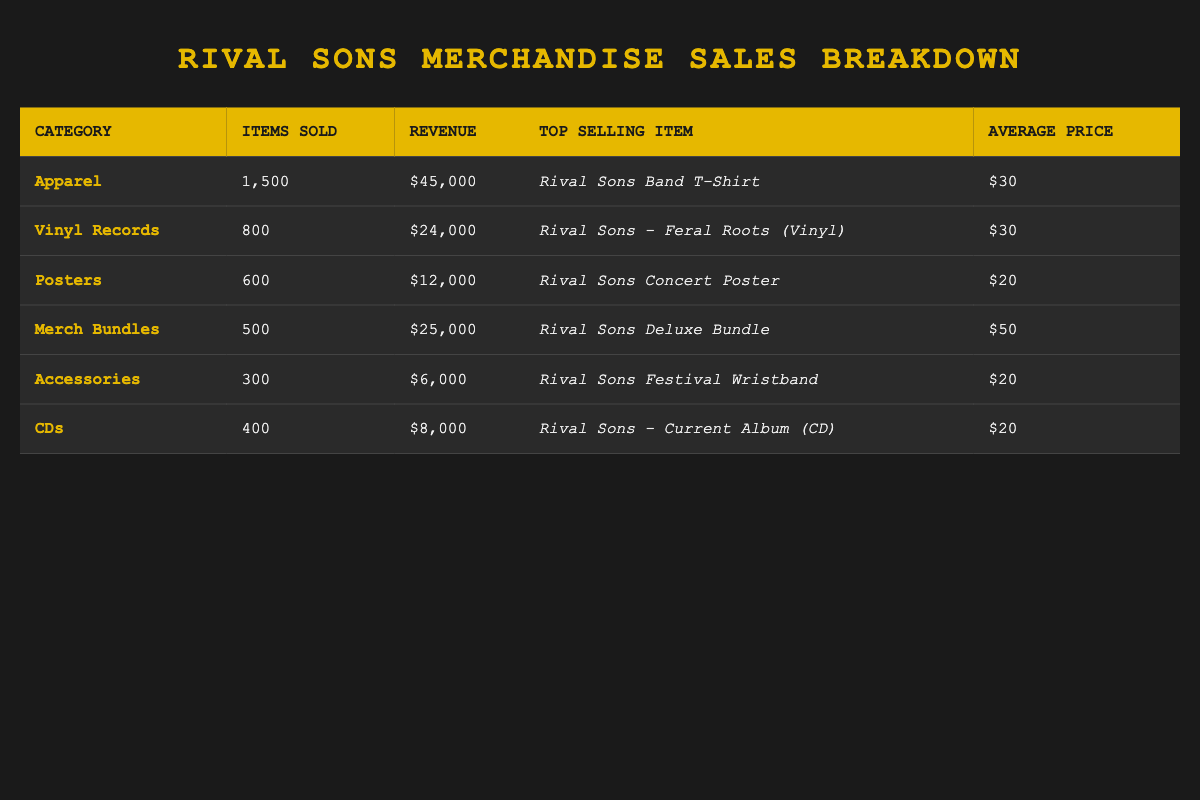What is the top-selling item in the Apparel category? In the table, under the Apparel category, the top-selling item is specified as "Rival Sons Band T-Shirt."
Answer: Rival Sons Band T-Shirt How many Vinyl Records were sold? The table notes that a total of 800 Vinyl Records were sold in that category.
Answer: 800 What is the total revenue generated from Merch Bundles? According to the table, the revenue from Merch Bundles is listed as $25,000.
Answer: 25,000 Which category has the highest average price per item? By comparing the average prices per item in each category, Merch Bundles at $50 has the highest average price.
Answer: Merch Bundles How many items were sold across all categories? To find the total items sold, sum up the items from each category: 1500 + 800 + 600 + 500 + 300 + 400 = 4100 items sold in total.
Answer: 4100 Is the revenue from Accessories greater than that from CDs? The revenue for Accessories is $6,000 and for CDs is $8,000. Since $6,000 is less than $8,000, the statement is false.
Answer: No What is the combined revenue from Posters and Accessories? The revenue for Posters is $12,000 and for Accessories is $6,000. Adding these gives $12,000 + $6,000 = $18,000 combined revenue.
Answer: 18,000 Which item category has sold more than 500 items? The categories that sold more than 500 items are Apparel (1500), Vinyl Records (800), and Posters (600).
Answer: Apparel, Vinyl Records, Posters What percentage of total revenue comes from Apparel? The total revenue from all categories is $45,000 (Apparel) + $24,000 (Vinyl Records) + $12,000 (Posters) + $25,000 (Merch Bundles) + $6,000 (Accessories) + $8,000 (CDs) = $120,000. The percentage from Apparel is ($45,000 / $120,000) * 100 = 37.5%.
Answer: 37.5% What is the difference in revenue between the highest and lowest earning categories? The highest revenue is from Apparel at $45,000, and the lowest is from Accessories at $6,000. The difference is $45,000 - $6,000 = $39,000.
Answer: 39,000 